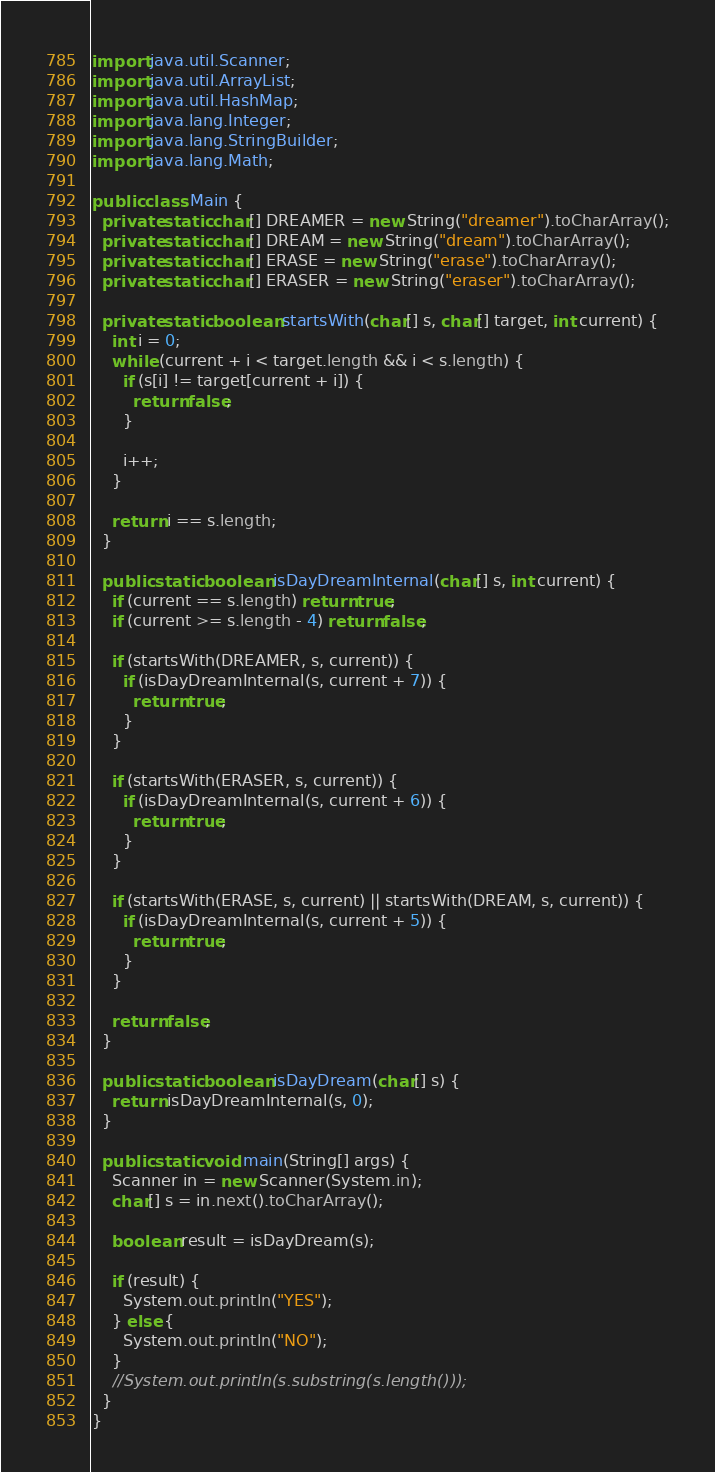Convert code to text. <code><loc_0><loc_0><loc_500><loc_500><_Java_>import java.util.Scanner;
import java.util.ArrayList;
import java.util.HashMap;
import java.lang.Integer;
import java.lang.StringBuilder;
import java.lang.Math;

public class Main {
  private static char[] DREAMER = new String("dreamer").toCharArray();
  private static char[] DREAM = new String("dream").toCharArray();
  private static char[] ERASE = new String("erase").toCharArray();
  private static char[] ERASER = new String("eraser").toCharArray();

  private static boolean startsWith(char[] s, char[] target, int current) {
    int i = 0;
    while (current + i < target.length && i < s.length) {
      if (s[i] != target[current + i]) {
        return false;
      }

      i++;
    }

    return i == s.length;
  }

  public static boolean isDayDreamInternal(char[] s, int current) {
    if (current == s.length) return true;
    if (current >= s.length - 4) return false;

    if (startsWith(DREAMER, s, current)) {
      if (isDayDreamInternal(s, current + 7)) {
        return true;
      }
    }

    if (startsWith(ERASER, s, current)) {
      if (isDayDreamInternal(s, current + 6)) {
        return true;
      }
    }

    if (startsWith(ERASE, s, current) || startsWith(DREAM, s, current)) {
      if (isDayDreamInternal(s, current + 5)) {
        return true;
      }
    }

    return false;
  }

  public static boolean isDayDream(char[] s) {
    return isDayDreamInternal(s, 0);
  }

  public static void main(String[] args) {
    Scanner in = new Scanner(System.in);
    char[] s = in.next().toCharArray();

    boolean result = isDayDream(s);

    if (result) {
      System.out.println("YES");
    } else {
      System.out.println("NO");
    }
    //System.out.println(s.substring(s.length()));
  }
}</code> 